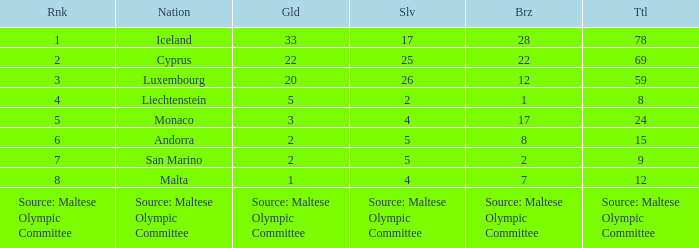Would you be able to parse every entry in this table? {'header': ['Rnk', 'Nation', 'Gld', 'Slv', 'Brz', 'Ttl'], 'rows': [['1', 'Iceland', '33', '17', '28', '78'], ['2', 'Cyprus', '22', '25', '22', '69'], ['3', 'Luxembourg', '20', '26', '12', '59'], ['4', 'Liechtenstein', '5', '2', '1', '8'], ['5', 'Monaco', '3', '4', '17', '24'], ['6', 'Andorra', '2', '5', '8', '15'], ['7', 'San Marino', '2', '5', '2', '9'], ['8', 'Malta', '1', '4', '7', '12'], ['Source: Maltese Olympic Committee', 'Source: Maltese Olympic Committee', 'Source: Maltese Olympic Committee', 'Source: Maltese Olympic Committee', 'Source: Maltese Olympic Committee', 'Source: Maltese Olympic Committee']]} What nation has 28 bronze medals? Iceland. 